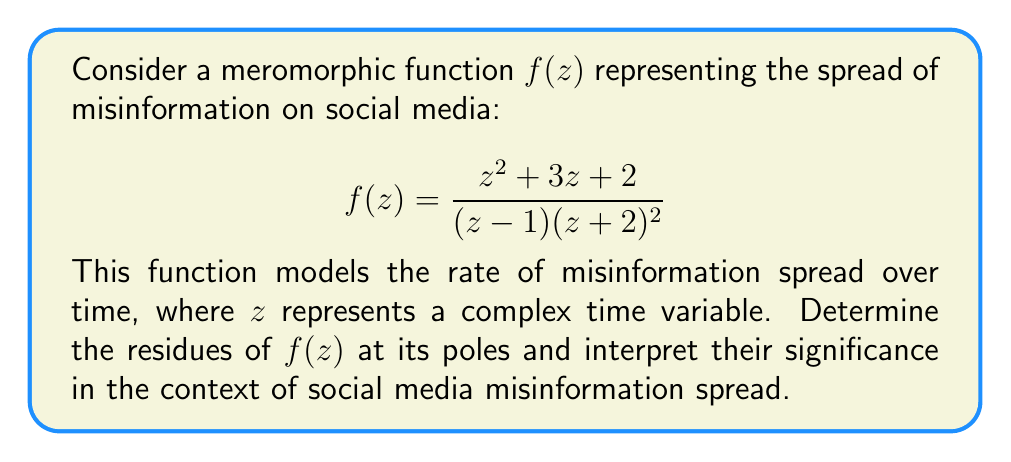Solve this math problem. To find the residues, we need to identify the poles of $f(z)$ and calculate the residues at each pole:

1. Identify the poles:
   The poles are at $z=1$ (simple pole) and $z=-2$ (double pole).

2. Calculate the residue at $z=1$ (simple pole):
   $$\text{Res}(f,1) = \lim_{z \to 1} (z-1)f(z) = \lim_{z \to 1} \frac{z^2 + 3z + 2}{(z+2)^2} = \frac{1^2 + 3(1) + 2}{(1+2)^2} = \frac{6}{9} = \frac{2}{3}$$

3. Calculate the residue at $z=-2$ (double pole):
   For a double pole, we use the formula: $\text{Res}(f,-2) = \lim_{z \to -2} \frac{d}{dz}[(z+2)^2f(z)]$

   First, simplify $(z+2)^2f(z)$:
   $$(z+2)^2f(z) = \frac{z^2 + 3z + 2}{z-1}$$

   Now differentiate:
   $$\frac{d}{dz}\left[\frac{z^2 + 3z + 2}{z-1}\right] = \frac{(2z+3)(z-1) - (z^2+3z+2)(-1)}{(z-1)^2}$$

   Evaluate the limit:
   $$\lim_{z \to -2} \frac{(2z+3)(z-1) - (z^2+3z+2)(-1)}{(z-1)^2} = \frac{(-1)(-3) - (4-6+2)(-1)}{(-3)^2} = \frac{3 - 0}{9} = \frac{1}{3}$$

Interpretation:
The residue at $z=1$ ($\frac{2}{3}$) represents the initial surge in misinformation spread, while the residue at $z=-2$ ($\frac{1}{3}$) represents the long-term persistence of misinformation in social networks.
Answer: Residues: $\text{Res}(f,1) = \frac{2}{3}$, $\text{Res}(f,-2) = \frac{1}{3}$ 